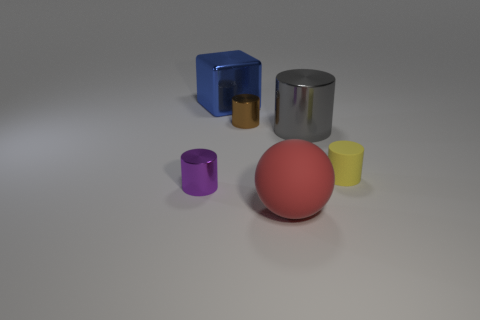Subtract all large cylinders. How many cylinders are left? 3 Subtract 1 cylinders. How many cylinders are left? 3 Subtract all yellow cylinders. How many cylinders are left? 3 Add 4 large red rubber spheres. How many objects exist? 10 Add 5 large blue metallic things. How many large blue metallic things exist? 6 Subtract 0 gray balls. How many objects are left? 6 Subtract all cubes. How many objects are left? 5 Subtract all cyan cubes. Subtract all blue balls. How many cubes are left? 1 Subtract all cyan cubes. How many green balls are left? 0 Subtract all small green matte cylinders. Subtract all cubes. How many objects are left? 5 